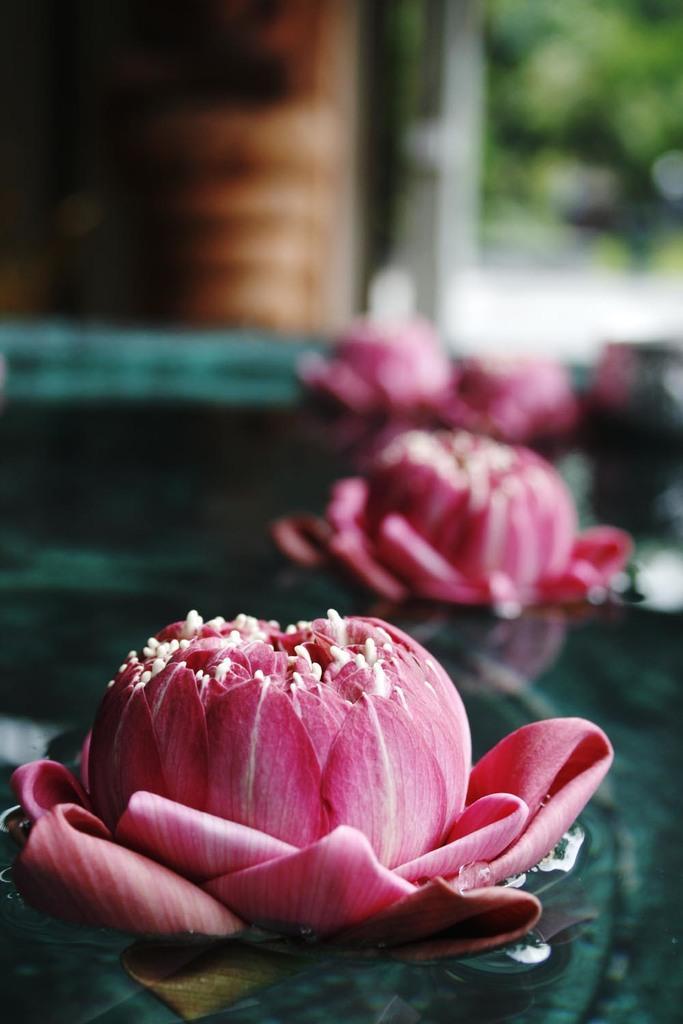Could you give a brief overview of what you see in this image? Here in this picture in the front we can see flower floating on the water and behind that also we can see same flowers present in water, but they are in blurry manner and in the far we can see plats and trees in blurry manner. 